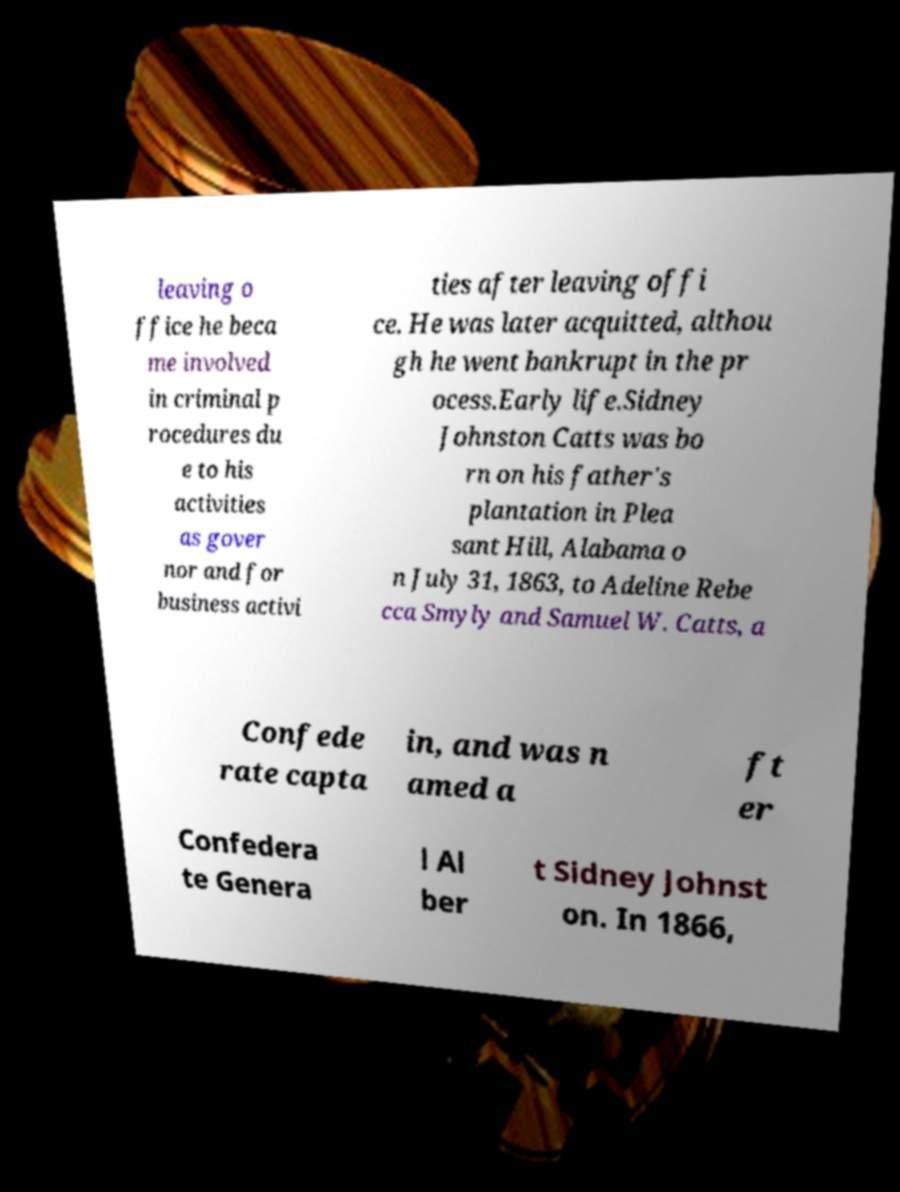I need the written content from this picture converted into text. Can you do that? leaving o ffice he beca me involved in criminal p rocedures du e to his activities as gover nor and for business activi ties after leaving offi ce. He was later acquitted, althou gh he went bankrupt in the pr ocess.Early life.Sidney Johnston Catts was bo rn on his father's plantation in Plea sant Hill, Alabama o n July 31, 1863, to Adeline Rebe cca Smyly and Samuel W. Catts, a Confede rate capta in, and was n amed a ft er Confedera te Genera l Al ber t Sidney Johnst on. In 1866, 